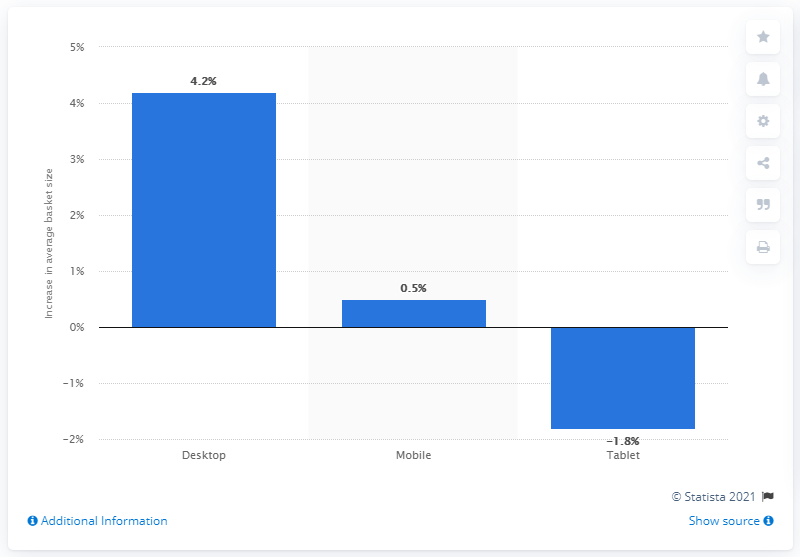How might these changes in device usage influence software development priorities? These changes could influence software developers to optimize their applications for desktop computers, ensuring superior performance and user experience on this form factor given its growth. They should not neglect mobile development due to its overall market dominance and slight increase. However, developers might deprioritize tablet-specific features or versions of their apps, unless there is a strategic niche market or use-case for tablets that they aim to target. 